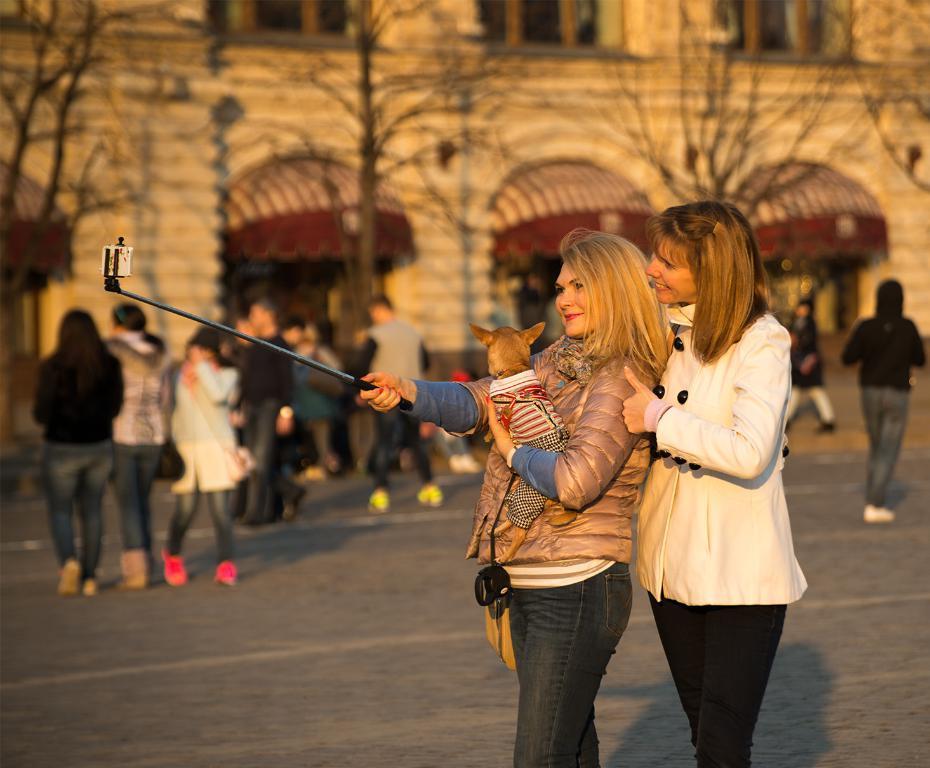Could you give a brief overview of what you see in this image? In this image I can see number of people are standing and in the front I can see one woman is holding a dog and a selfie stick. In the background I can see number of trees, a building, windows and I can also see this image is little bit blurry. 